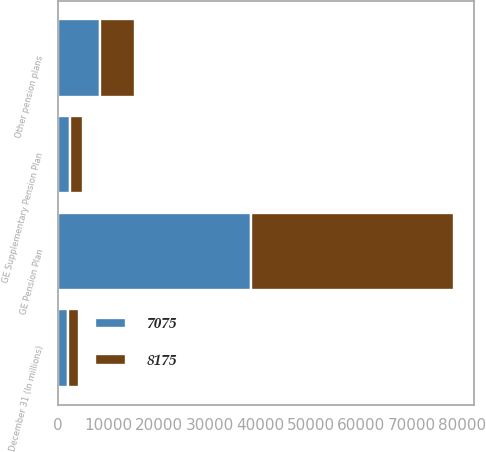<chart> <loc_0><loc_0><loc_500><loc_500><stacked_bar_chart><ecel><fcel>December 31 (In millions)<fcel>GE Pension Plan<fcel>GE Supplementary Pension Plan<fcel>Other pension plans<nl><fcel>8175<fcel>2008<fcel>40313<fcel>2582<fcel>7075<nl><fcel>7075<fcel>2007<fcel>38155<fcel>2292<fcel>8175<nl></chart> 